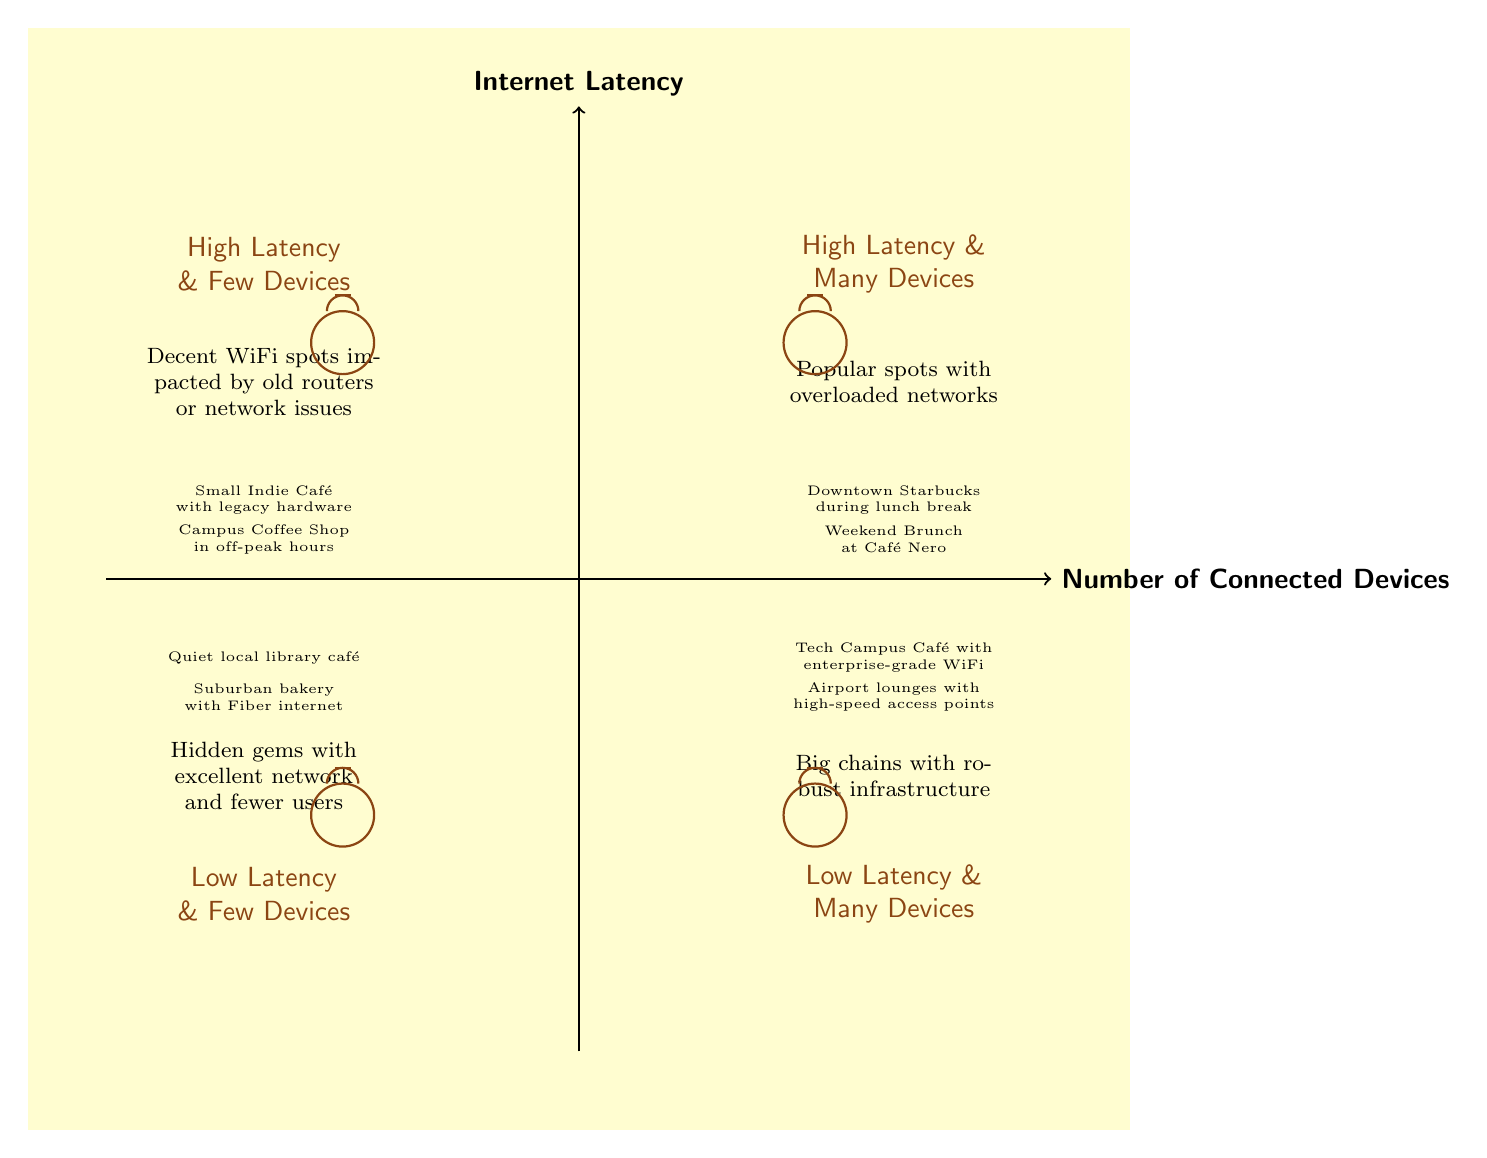What is in the High Latency & Few Devices quadrant? This quadrant represents decent WiFi spots that are impacted by old routers or network issues. Specific examples listed include a Small Indie Café with legacy hardware and a Campus Coffee Shop in off-peak hours.
Answer: Decent WiFi spots impacted by old routers or network issues How many examples are listed in the Low Latency & Many Devices quadrant? The Low Latency & Many Devices quadrant has two examples provided: Tech Campus Café with enterprise-grade WiFi and Airport lounges with high-speed access points.
Answer: 2 Which quadrant contains "Downtown Starbucks during lunch break"? "Downtown Starbucks during lunch break" is listed as an example under the High Latency & Many Devices quadrant.
Answer: High Latency & Many Devices What is the description for the Low Latency & Few Devices quadrant? The description for the Low Latency & Few Devices quadrant is that it includes hidden gems with excellent network and fewer users.
Answer: Hidden gems with excellent network and fewer users What is the common characteristic of the High Latency & Many Devices quadrant? This quadrant is characterized by popular spots that experience overloaded networks due to a high number of connected devices, leading to high latency.
Answer: Overloaded networks What type of café is an example of High Latency & Few Devices? An example given for this quadrant is a Small Indie Café with legacy hardware, which indicates it is a type of café affected by older technology.
Answer: Small Indie Café with legacy hardware Which quadrant would you choose for a reliable working environment with many users? For a reliable working environment with many users, one should choose the Low Latency & Many Devices quadrant, as it includes places with robust infrastructure supporting a high number of connected devices.
Answer: Low Latency & Many Devices What is the relationship between "Indoor Libraries" and latency? Indoor Libraries, as represented in the Low Latency & Few Devices quadrant, benefit from excellent networks and fewer users, implying a direct correlation with low latency and minimal congestion.
Answer: Low latency 